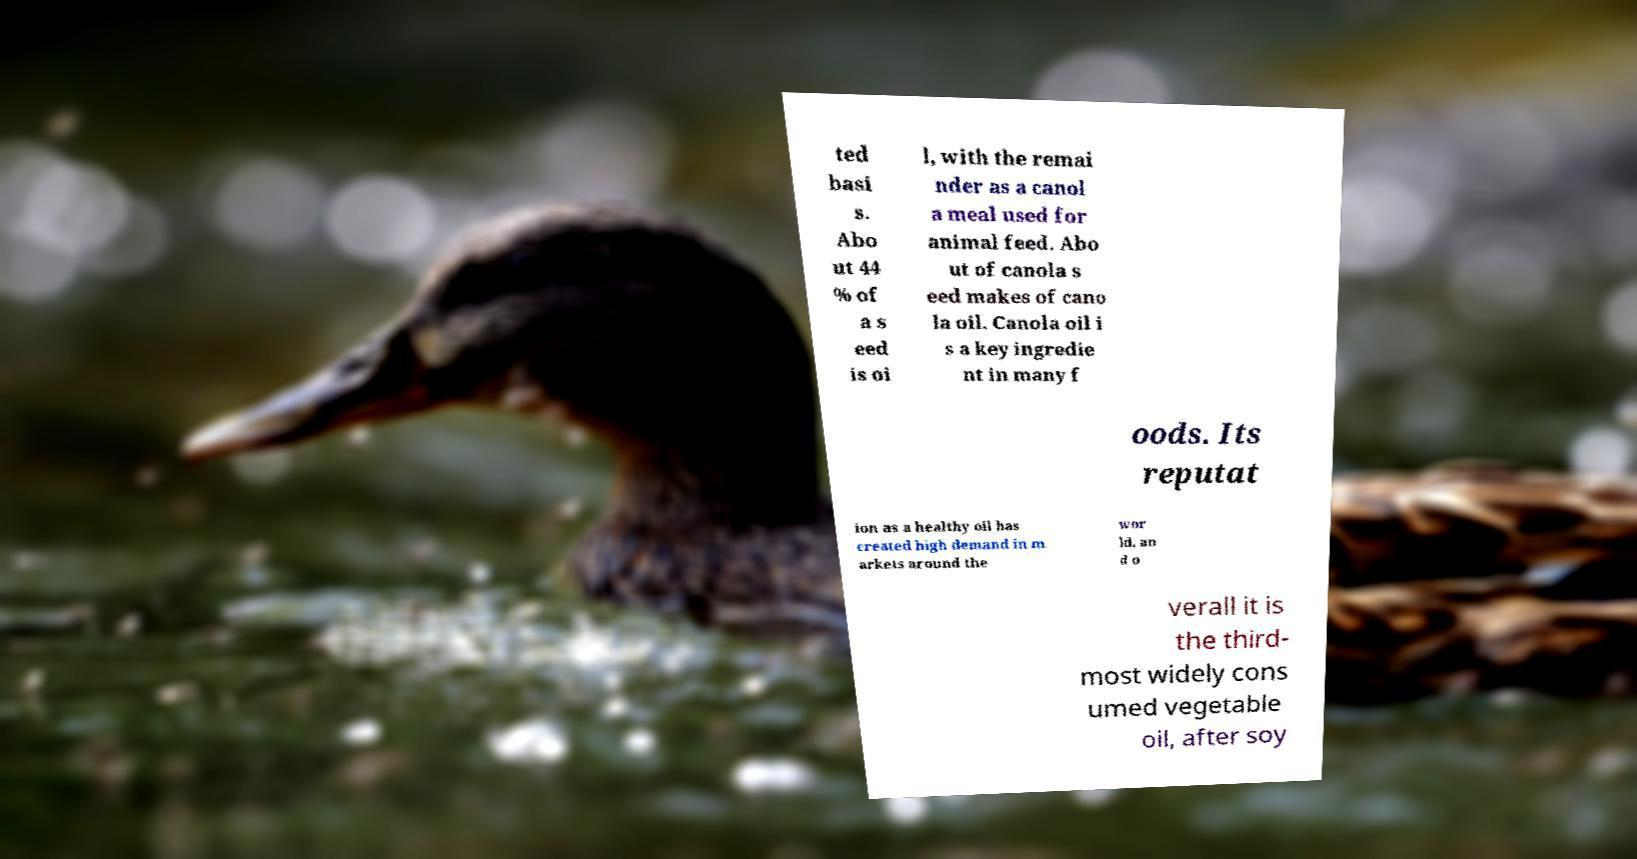Could you extract and type out the text from this image? ted basi s. Abo ut 44 % of a s eed is oi l, with the remai nder as a canol a meal used for animal feed. Abo ut of canola s eed makes of cano la oil. Canola oil i s a key ingredie nt in many f oods. Its reputat ion as a healthy oil has created high demand in m arkets around the wor ld, an d o verall it is the third- most widely cons umed vegetable oil, after soy 